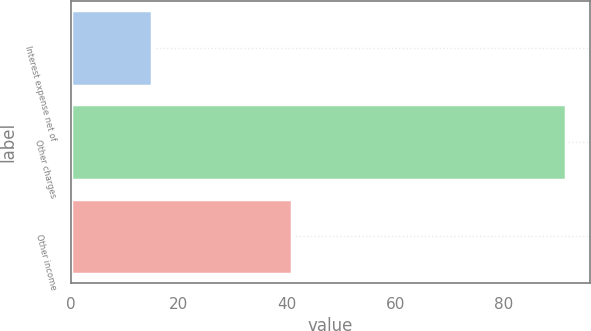<chart> <loc_0><loc_0><loc_500><loc_500><bar_chart><fcel>Interest expense net of<fcel>Other charges<fcel>Other income<nl><fcel>15.1<fcel>91.4<fcel>40.8<nl></chart> 